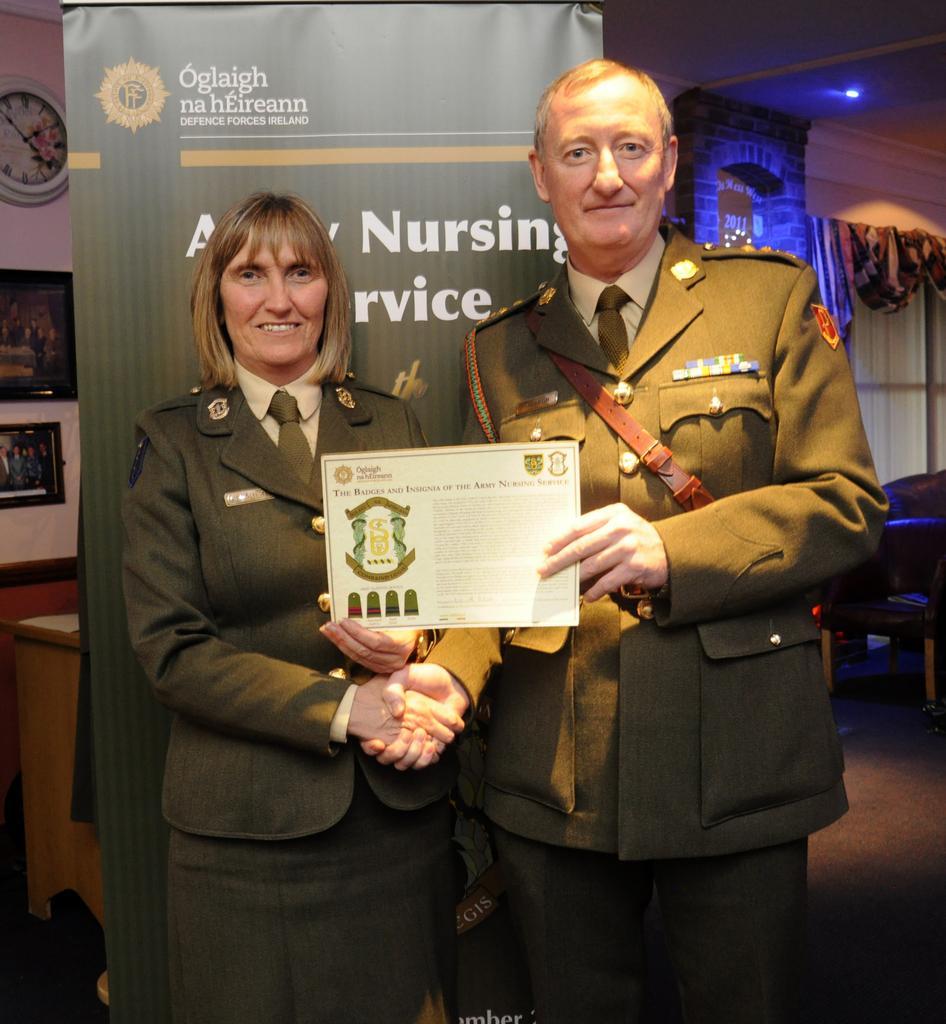Please provide a concise description of this image. A man is standing with a certificate in his hands and shaking the hands with a woman who is standing beside of him both of them wear a military dress behind them there is a banner and there are lights in the right. 